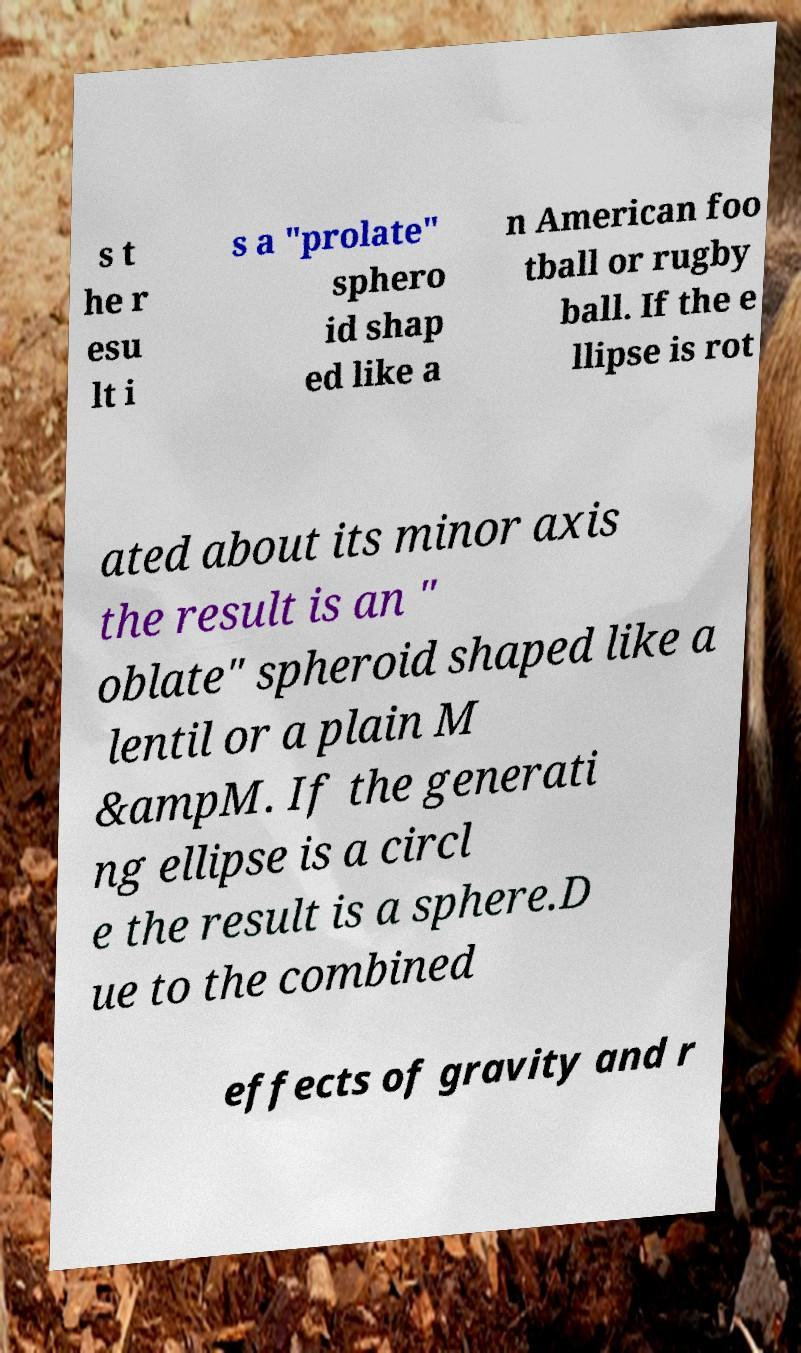For documentation purposes, I need the text within this image transcribed. Could you provide that? s t he r esu lt i s a "prolate" sphero id shap ed like a n American foo tball or rugby ball. If the e llipse is rot ated about its minor axis the result is an " oblate" spheroid shaped like a lentil or a plain M &ampM. If the generati ng ellipse is a circl e the result is a sphere.D ue to the combined effects of gravity and r 